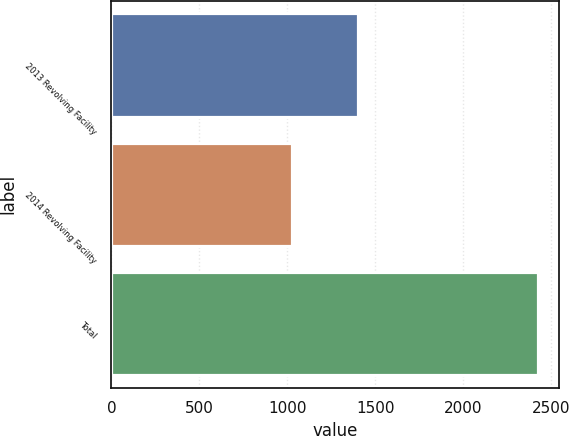Convert chart to OTSL. <chart><loc_0><loc_0><loc_500><loc_500><bar_chart><fcel>2013 Revolving Facility<fcel>2014 Revolving Facility<fcel>Total<nl><fcel>1400<fcel>1025<fcel>2425<nl></chart> 